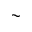Convert formula to latex. <formula><loc_0><loc_0><loc_500><loc_500>\sim</formula> 